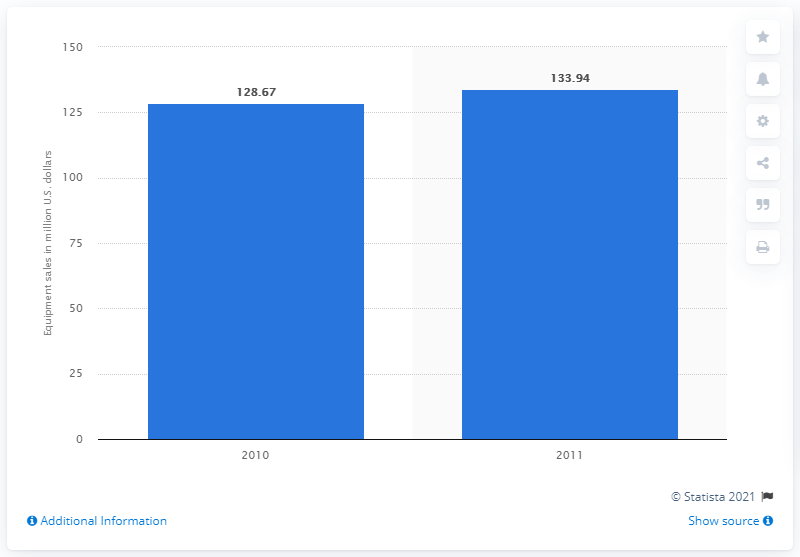Highlight a few significant elements in this photo. The total sales of lanterns/lighting products in the United States in 2010 were 128.67. 